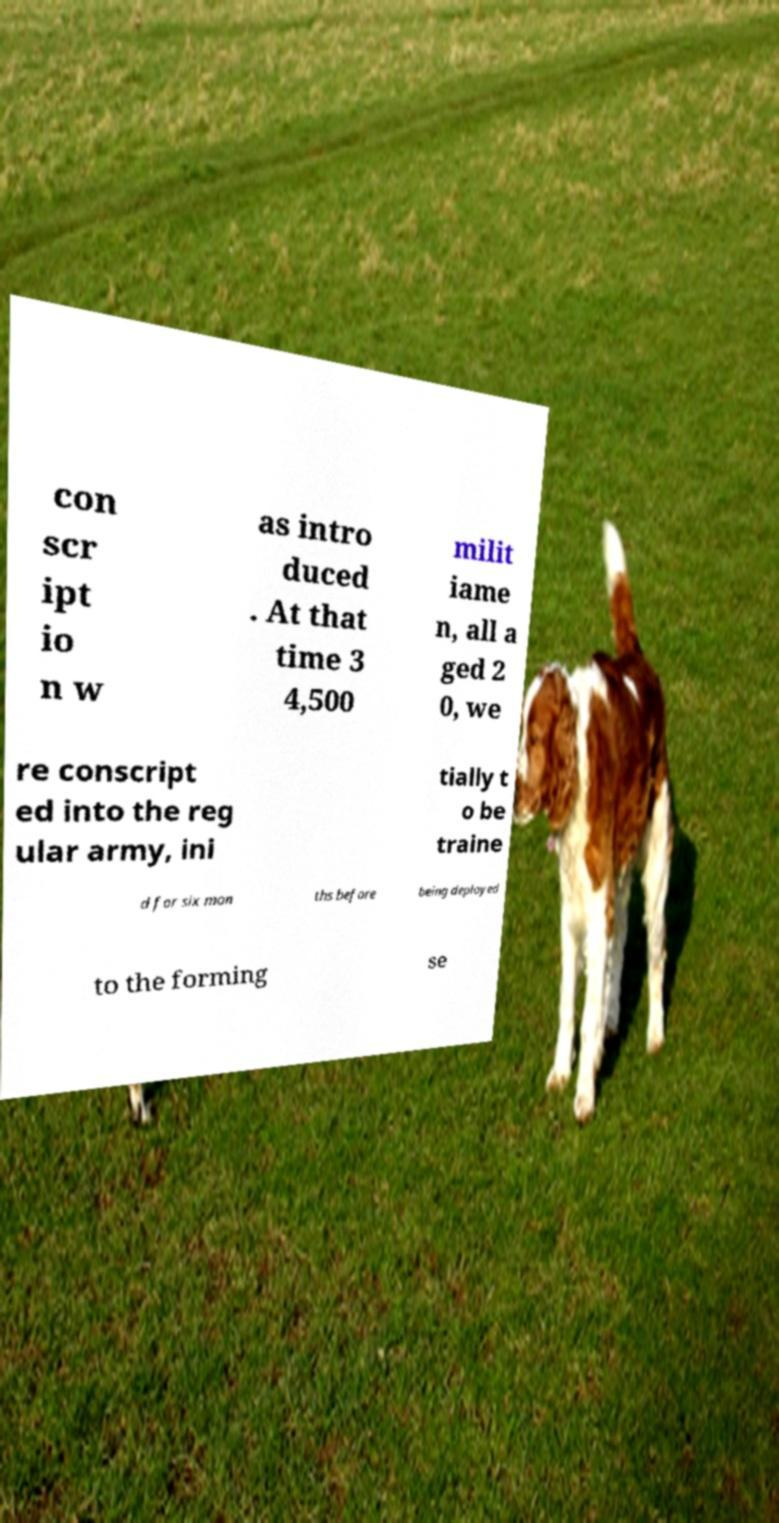There's text embedded in this image that I need extracted. Can you transcribe it verbatim? con scr ipt io n w as intro duced . At that time 3 4,500 milit iame n, all a ged 2 0, we re conscript ed into the reg ular army, ini tially t o be traine d for six mon ths before being deployed to the forming se 